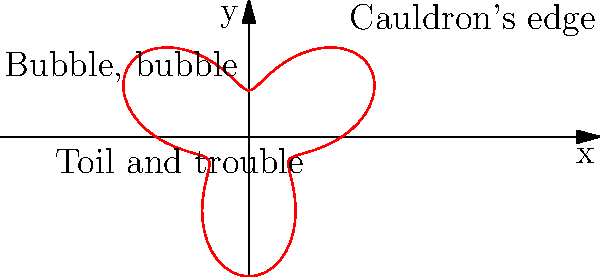In this polar graph representation of the witches' cauldron from Macbeth, the edge of the cauldron is defined by the equation $r = 2 + \sin(3\theta)$. How many lobes (outward curves) does the cauldron's edge have? To determine the number of lobes in the polar graph, we need to analyze the equation and its periodicity:

1. The equation is $r = 2 + \sin(3\theta)$
2. The sine function has a period of $2\pi$
3. In this case, the argument of sine is $3\theta$, which means the period of the entire function is $\frac{2\pi}{3}$
4. To find the number of lobes, we need to calculate how many complete periods occur in the full $2\pi$ rotation:
   $$\text{Number of lobes} = \frac{2\pi}{\frac{2\pi}{3}} = 3$$
5. We can also visually confirm this by counting the outward curves in the graph

Therefore, the cauldron's edge has 3 lobes, symbolizing the three witches in Macbeth or the tripled incantations often used in their spells ("Double, double toil and trouble; Fire burn and cauldron bubble").
Answer: 3 lobes 